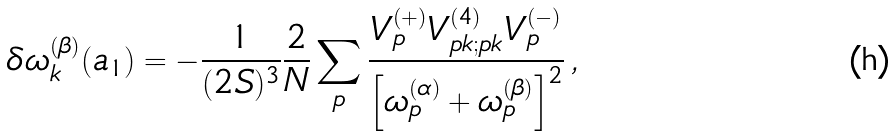Convert formula to latex. <formula><loc_0><loc_0><loc_500><loc_500>\delta \omega _ { k } ^ { ( \beta ) } ( a _ { 1 } ) = - \frac { 1 } { ( 2 S ) ^ { 3 } } \frac { 2 } { N } \sum _ { p } \frac { V ^ { ( + ) } _ { p } V ^ { ( 4 ) } _ { p k ; p k } V ^ { ( - ) } _ { p } } { \left [ \omega ^ { ( \alpha ) } _ { p } + \omega ^ { ( \beta ) } _ { p } \right ] ^ { 2 } } \, ,</formula> 